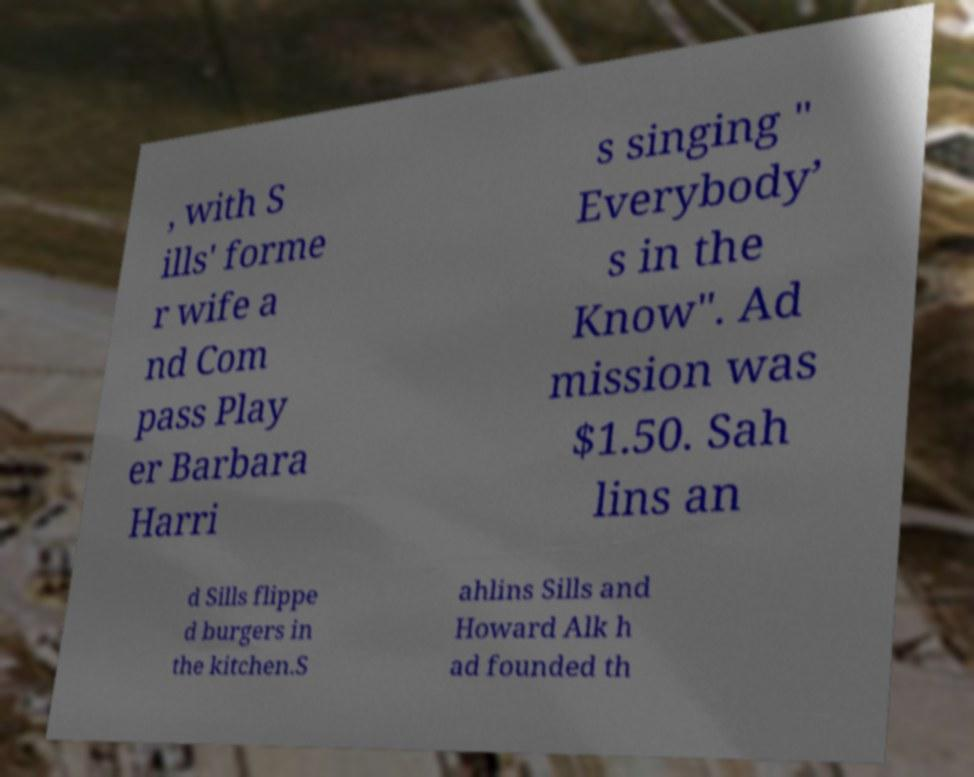What messages or text are displayed in this image? I need them in a readable, typed format. , with S ills' forme r wife a nd Com pass Play er Barbara Harri s singing " Everybody’ s in the Know". Ad mission was $1.50. Sah lins an d Sills flippe d burgers in the kitchen.S ahlins Sills and Howard Alk h ad founded th 